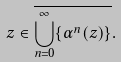Convert formula to latex. <formula><loc_0><loc_0><loc_500><loc_500>z \in \overline { \bigcup _ { n = 0 } ^ { \infty } \{ \alpha ^ { n } ( z ) \} } .</formula> 